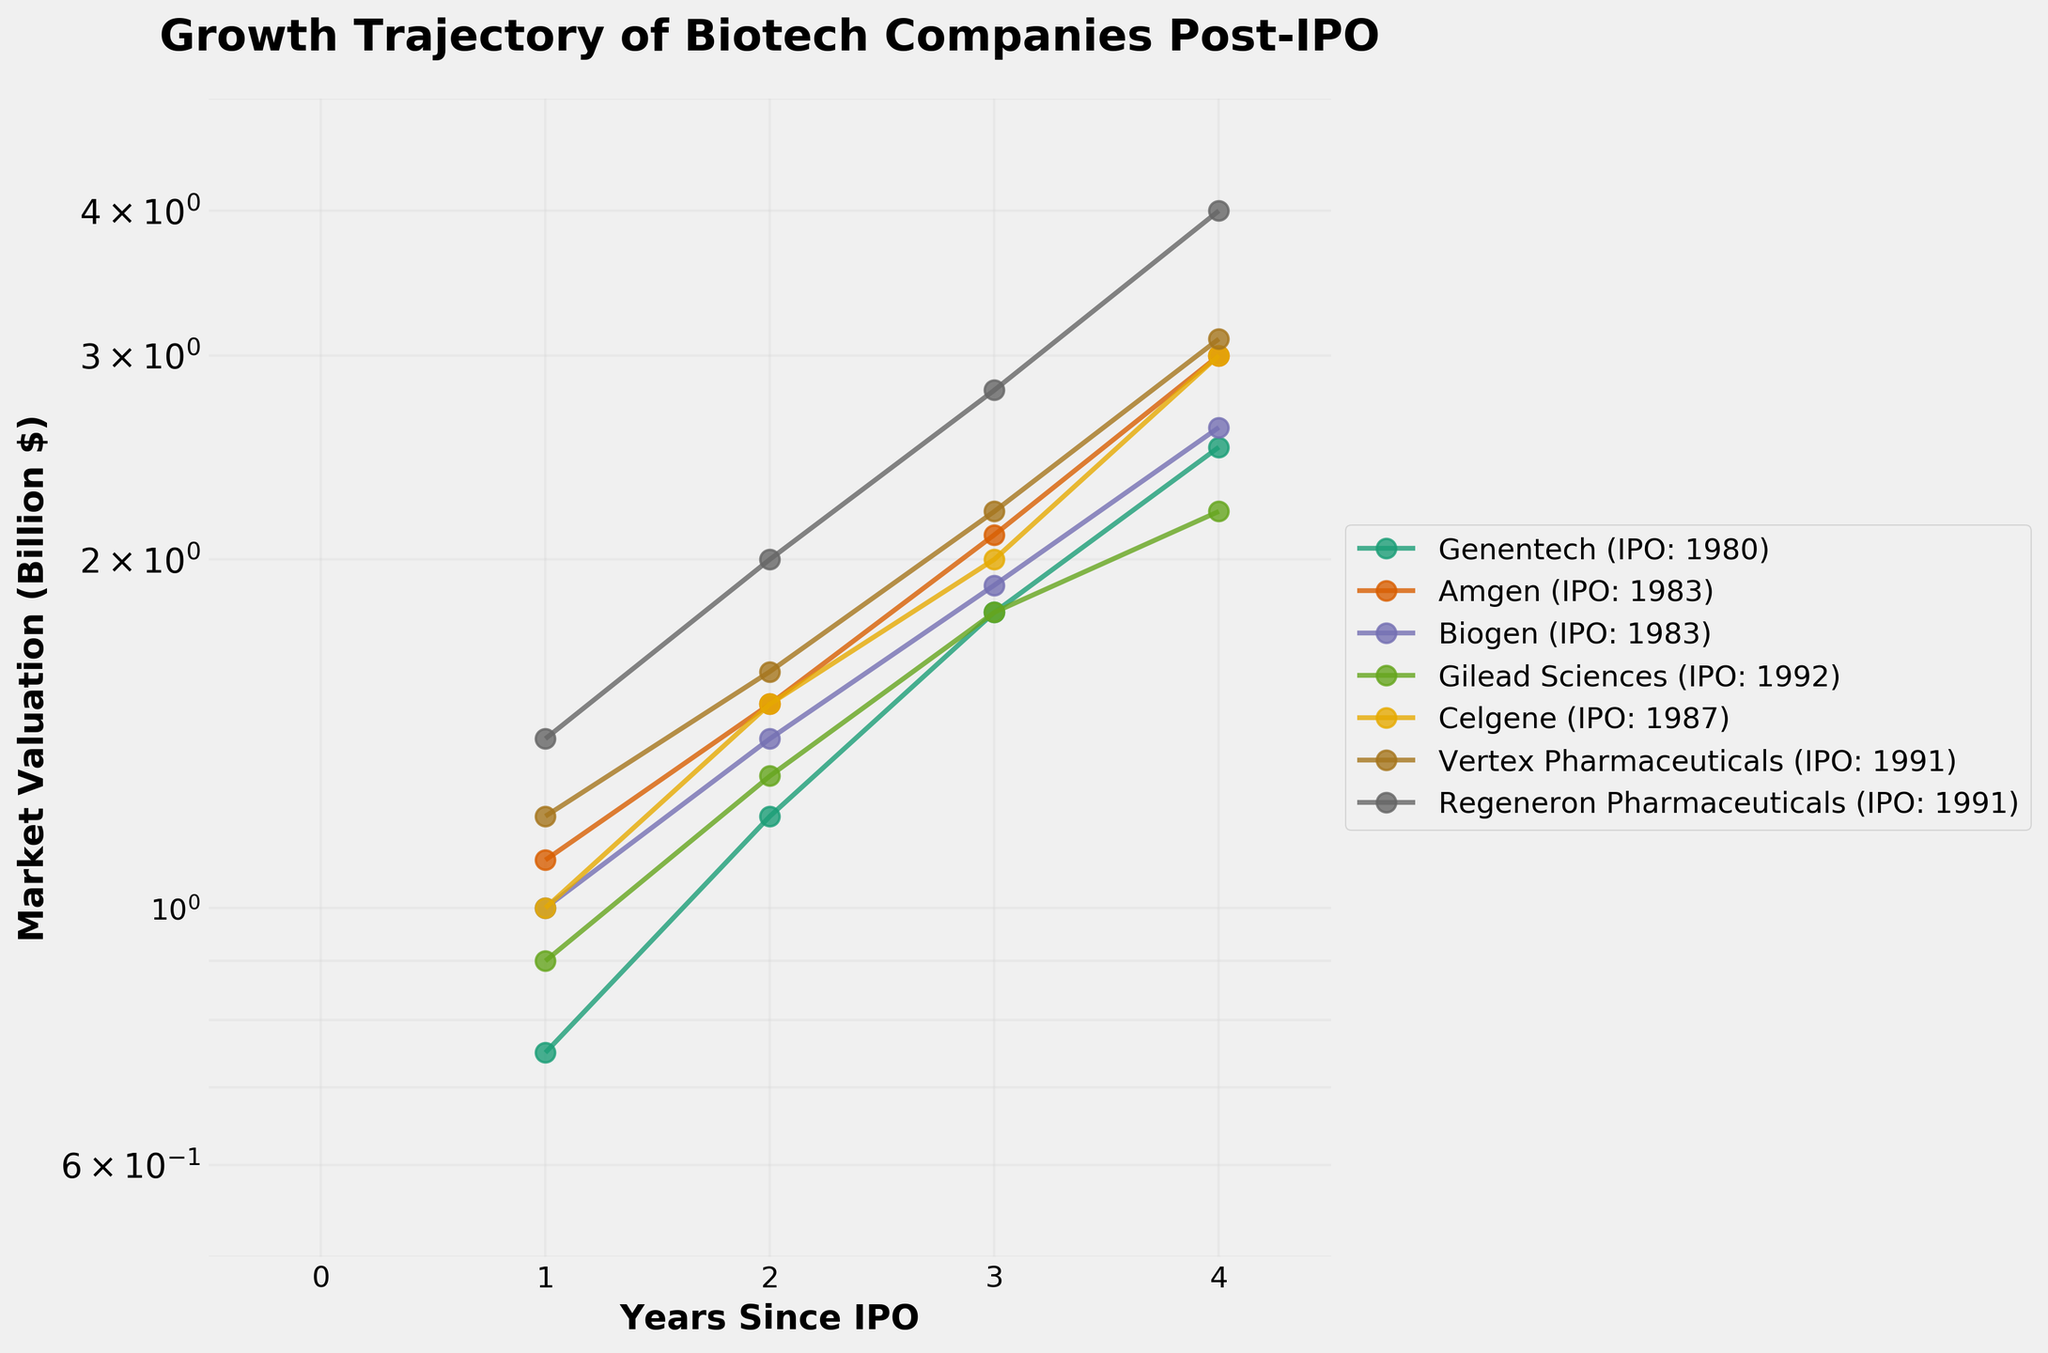What is the title of the figure? The title of a figure is usually the largest text positioned at the top. In this case, it reads "Growth Trajectory of Biotech Companies Post-IPO," indicating the overall theme of the plot.
Answer: Growth Trajectory of Biotech Companies Post-IPO What does the x-axis represent? The x-axis is labeled "Years Since IPO," showing that it represents the number of years since each company's initial public offering.
Answer: Years Since IPO How many companies are represented in the plot? The legend shows the names of the companies, each assigned a unique color. Counting these names gives the total number of companies represented.
Answer: 7 Which company had the highest market valuation in their third year post-IPO? To answer this, look three years from the IPO (Years Since IPO = 3) for each company and compare the market valuations. Regeneron Pharmaceuticals shows a market valuation of 4.0 billion dollars, the highest.
Answer: Regeneron Pharmaceuticals Which company shows the steepest growth in market valuation over time? Identify the company with the steepest upward trend in the figure. Regeneron Pharmaceuticals has the steepest growth trajectory, rising from 1.4 billion to 4.0 billion dollars within four years.
Answer: Regeneron Pharmaceuticals What is the range of market valuations displayed on the y-axis? The y-axis ranges from 0.5 to 5 billion dollars, as visible on the plot's left side.
Answer: 0.5 to 5 billion dollars How did Genentech’s market valuation change in the first four years post-IPO? Locate the line representing Genentech and observe the market valuations over the first four years. The valuation increased from 0.75 billion to 2.5 billion dollars.
Answer: Increased from 0.75 billion to 2.5 billion dollars Which companies had their IPOs in the year 1983? Refer to the legend where IPO years are indicated next to company names. Both Amgen and Biogen had their IPOs in 1983.
Answer: Amgen and Biogen Out of the companies listed, which had their market valuation double the soonest after IPO? Find the company whose market valuation reached double its IPO value the quickest. Regeneron Pharmaceuticals reached 2.8 billion dollars from an IPO value of 1.4 billion dollars, within three years post-IPO.
Answer: Regeneron Pharmaceuticals Compare the market valuation growth trajectories of Amgen and Biogen. Which one shows a more consistent growth trend? Inspect the lines representing Amgen and Biogen. Both show steady growth, but Biogen has a more consistent slope without sharp increases or dips.
Answer: Biogen 